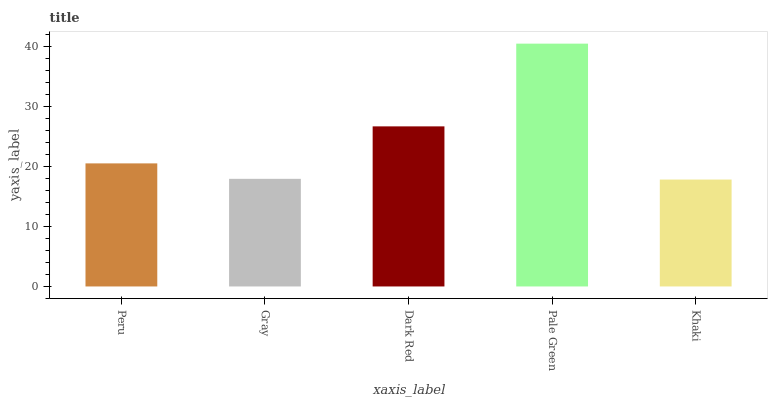Is Khaki the minimum?
Answer yes or no. Yes. Is Pale Green the maximum?
Answer yes or no. Yes. Is Gray the minimum?
Answer yes or no. No. Is Gray the maximum?
Answer yes or no. No. Is Peru greater than Gray?
Answer yes or no. Yes. Is Gray less than Peru?
Answer yes or no. Yes. Is Gray greater than Peru?
Answer yes or no. No. Is Peru less than Gray?
Answer yes or no. No. Is Peru the high median?
Answer yes or no. Yes. Is Peru the low median?
Answer yes or no. Yes. Is Dark Red the high median?
Answer yes or no. No. Is Khaki the low median?
Answer yes or no. No. 